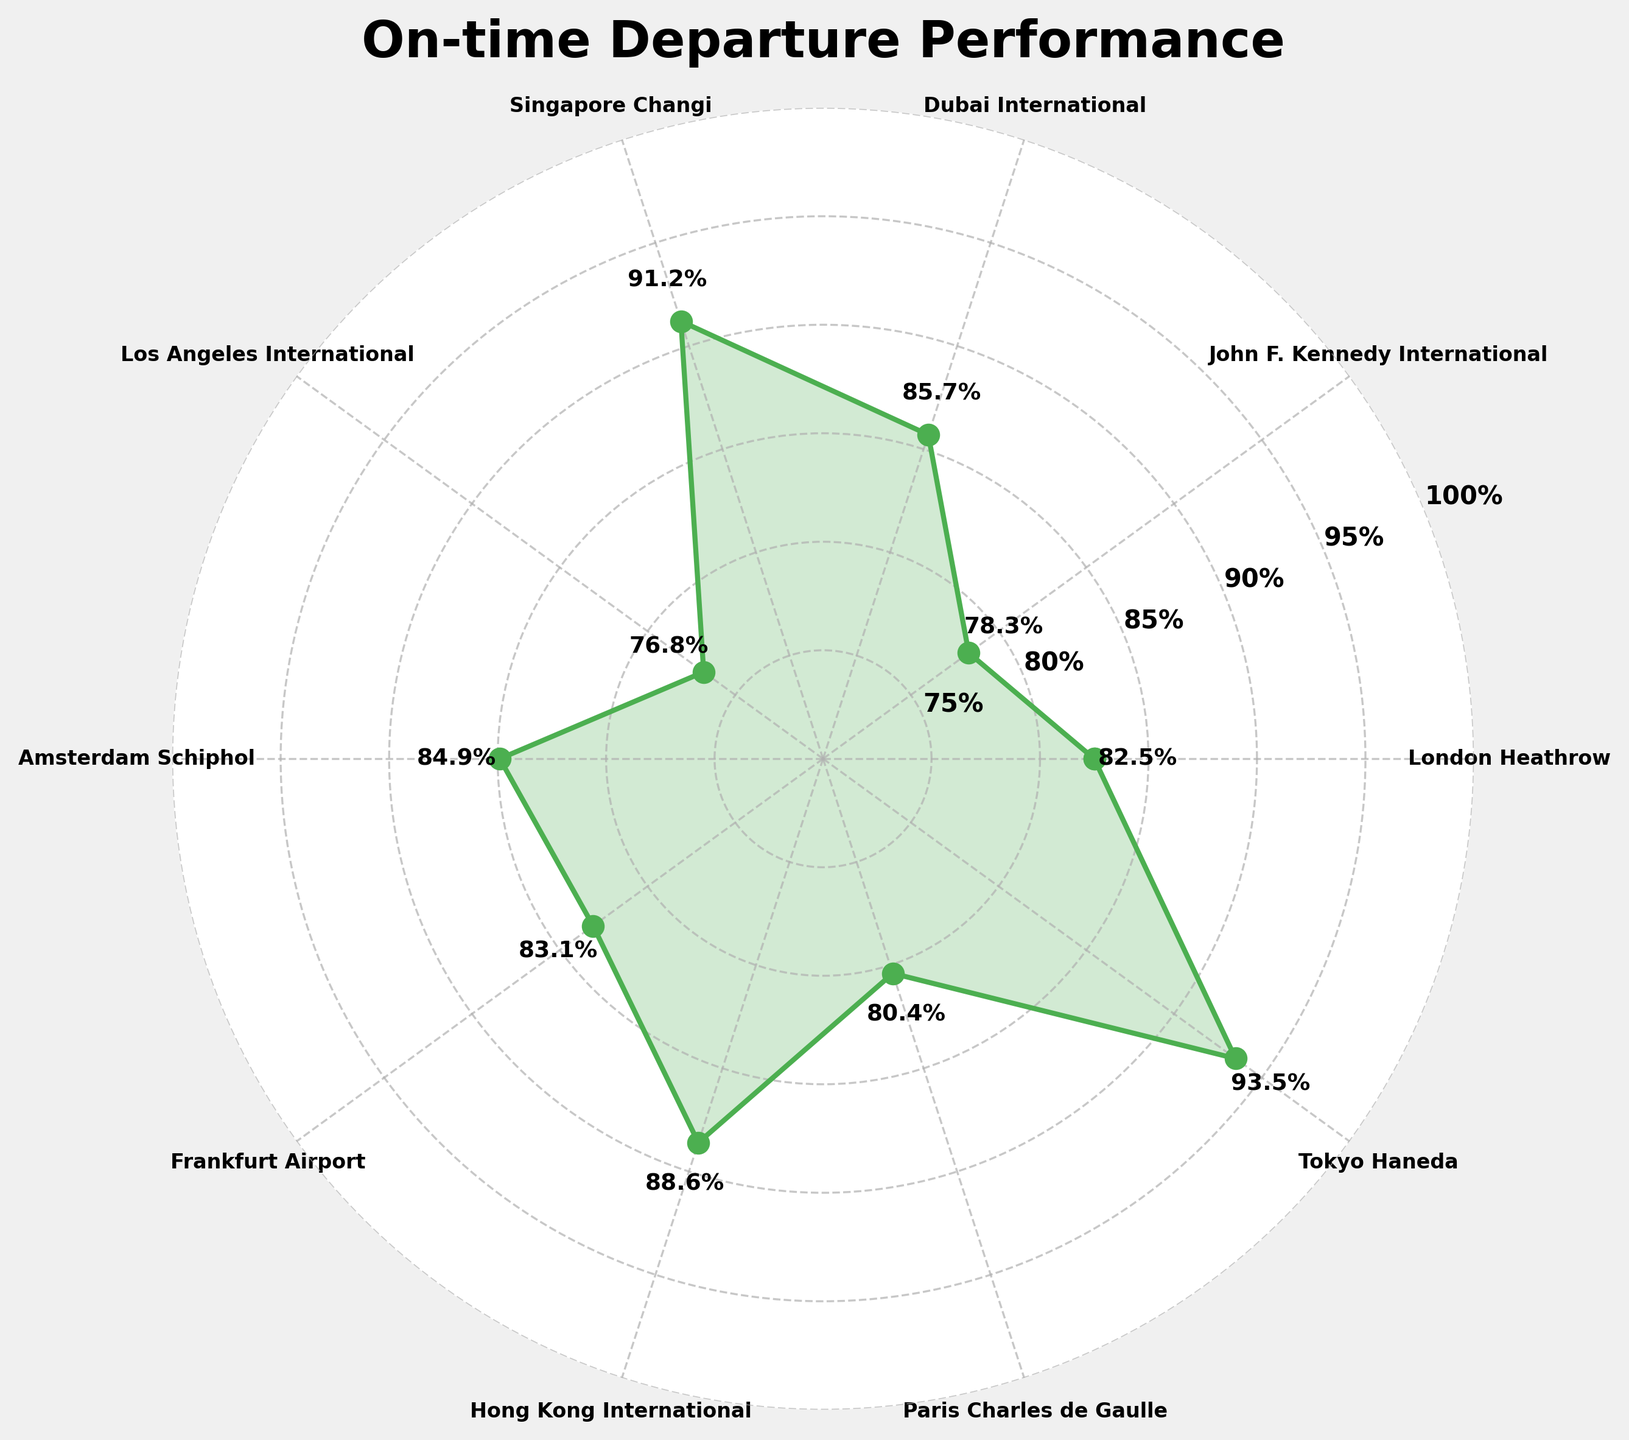What's the title of the figure? The title is located at the top of the figure. We can see it clearly above the polar plot.
Answer: On-time Departure Performance What is the range of y-axis values shown in the figure? The y-axis values, located in a circular array in the polar plot, range from 75% to 100% as indicated by the tick marks and labels.
Answer: 75% to 100% Which airport has the highest on-time departure percentage? According to the figure, we need to look at the airport corresponding to the highest point on the polar plot. Tokyo Haneda (93.5%) is the highest.
Answer: Tokyo Haneda What is the on-time departure percentage for London Heathrow? The figure labels the percentage for each airport at its respective data point. By locating London Heathrow, we see its percentage as 82.5%.
Answer: 82.5% Compare the on-time departure percentages of Amsterdam Schiphol and Frankfurt Airport. Which one is higher? We compare the data points for Amsterdam Schiphol (84.9%) and Frankfurt Airport (83.1%) as labeled in the figure. Amsterdam Schiphol is higher.
Answer: Amsterdam Schiphol What is the average on-time departure percentage across all the airports? We sum the percentages and then divide by the number of airports: (82.5 + 78.3 + 85.7 + 91.2 + 76.8 + 84.9 + 83.1 + 88.6 + 80.4 + 93.5) / 10 = 84.5%.
Answer: 84.5% What is the difference in on-time departure percentage between Los Angeles International and Singapore Changi? Subtract the percentage of Los Angeles International (76.8%) from the percentage of Singapore Changi (91.2%). The difference is 91.2% - 76.8% = 14.4%.
Answer: 14.4% Which airport has the lowest on-time departure percentage? Identify the lowest point on the polar plot. John F. Kennedy International has the lowest with 78.3%.
Answer: John F. Kennedy International What are the on-time departure percentages for airports in the USA? The figure provides the percentages for two US airports: John F. Kennedy International with 78.3% and Los Angeles International with 76.8%.
Answer: 78.3% and 76.8% How many airports have an on-time departure percentage higher than 85%? By checking each percentage on the figure, the airports with greater than 85% are: Dubai International (85.7%), Singapore Changi (91.2%), Hong Kong International (88.6%), and Tokyo Haneda (93.5%). Four airports in total.
Answer: 4 